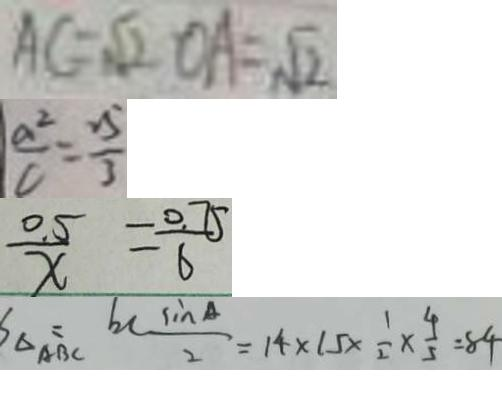<formula> <loc_0><loc_0><loc_500><loc_500>A C = \sqrt { 2 } O A = \sqrt { 2 } 
 \frac { a ^ { 2 } } { c } = \frac { 2 5 } { 3 } 
 \frac { 0 . 5 } { x } = \frac { 0 . 7 5 } { 6 } 
 S _ { \Delta A B C } = b c \frac { \sin A } { 2 } = 1 4 \times 1 5 \times \frac { 1 } { 2 } \times \frac { 4 } { 5 } = 8 4</formula> 